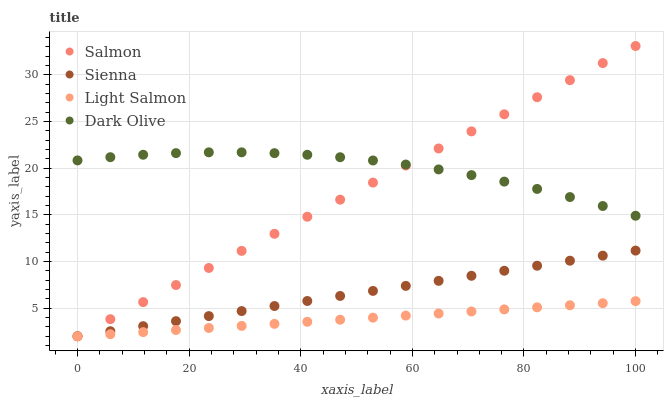Does Light Salmon have the minimum area under the curve?
Answer yes or no. Yes. Does Dark Olive have the maximum area under the curve?
Answer yes or no. Yes. Does Dark Olive have the minimum area under the curve?
Answer yes or no. No. Does Light Salmon have the maximum area under the curve?
Answer yes or no. No. Is Light Salmon the smoothest?
Answer yes or no. Yes. Is Dark Olive the roughest?
Answer yes or no. Yes. Is Dark Olive the smoothest?
Answer yes or no. No. Is Light Salmon the roughest?
Answer yes or no. No. Does Sienna have the lowest value?
Answer yes or no. Yes. Does Dark Olive have the lowest value?
Answer yes or no. No. Does Salmon have the highest value?
Answer yes or no. Yes. Does Dark Olive have the highest value?
Answer yes or no. No. Is Light Salmon less than Dark Olive?
Answer yes or no. Yes. Is Dark Olive greater than Light Salmon?
Answer yes or no. Yes. Does Salmon intersect Light Salmon?
Answer yes or no. Yes. Is Salmon less than Light Salmon?
Answer yes or no. No. Is Salmon greater than Light Salmon?
Answer yes or no. No. Does Light Salmon intersect Dark Olive?
Answer yes or no. No. 